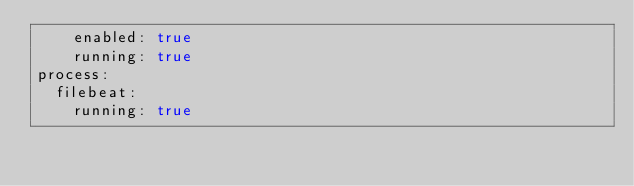Convert code to text. <code><loc_0><loc_0><loc_500><loc_500><_YAML_>    enabled: true
    running: true
process:
  filebeat:
    running: true
</code> 